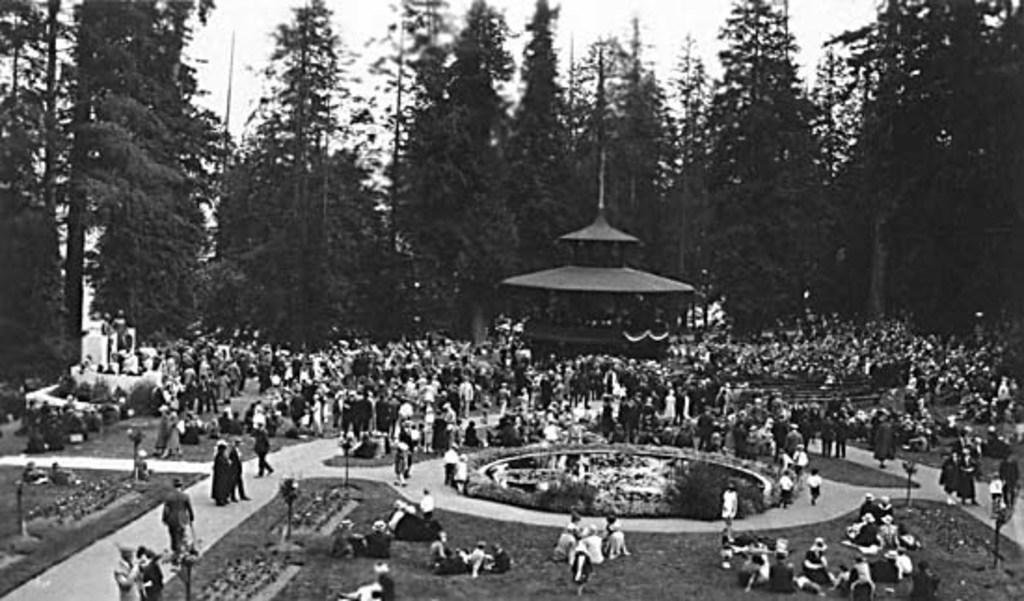What is the color scheme of the image? The image is black and white. How many people can be seen in the image? There are many people in the image. What is the main structure in the image? There is a building at the center of the image. What type of natural elements can be seen in the background of the image? There are trees and the sky visible in the background of the image. What type of wood is being used to construct the tank in the image? There is no tank present in the image, and therefore no wood being used for construction. 